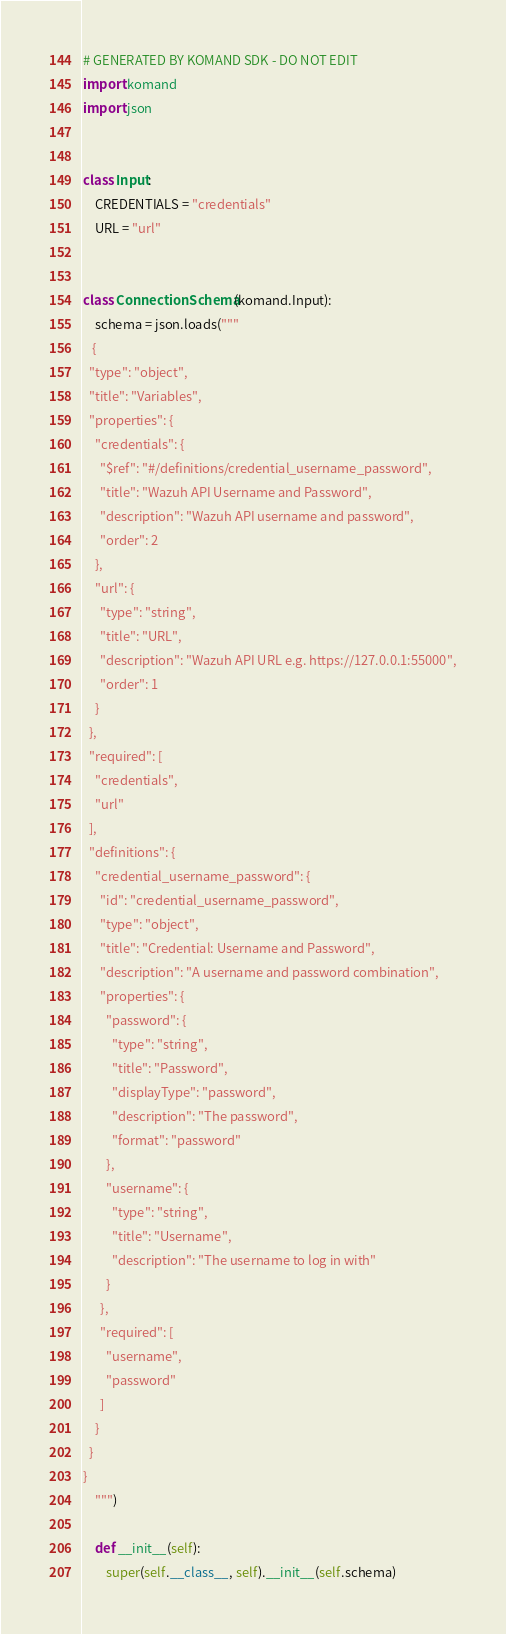Convert code to text. <code><loc_0><loc_0><loc_500><loc_500><_Python_># GENERATED BY KOMAND SDK - DO NOT EDIT
import komand
import json


class Input:
    CREDENTIALS = "credentials"
    URL = "url"
    

class ConnectionSchema(komand.Input):
    schema = json.loads("""
   {
  "type": "object",
  "title": "Variables",
  "properties": {
    "credentials": {
      "$ref": "#/definitions/credential_username_password",
      "title": "Wazuh API Username and Password",
      "description": "Wazuh API username and password",
      "order": 2
    },
    "url": {
      "type": "string",
      "title": "URL",
      "description": "Wazuh API URL e.g. https://127.0.0.1:55000",
      "order": 1
    }
  },
  "required": [
    "credentials",
    "url"
  ],
  "definitions": {
    "credential_username_password": {
      "id": "credential_username_password",
      "type": "object",
      "title": "Credential: Username and Password",
      "description": "A username and password combination",
      "properties": {
        "password": {
          "type": "string",
          "title": "Password",
          "displayType": "password",
          "description": "The password",
          "format": "password"
        },
        "username": {
          "type": "string",
          "title": "Username",
          "description": "The username to log in with"
        }
      },
      "required": [
        "username",
        "password"
      ]
    }
  }
}
    """)

    def __init__(self):
        super(self.__class__, self).__init__(self.schema)
</code> 